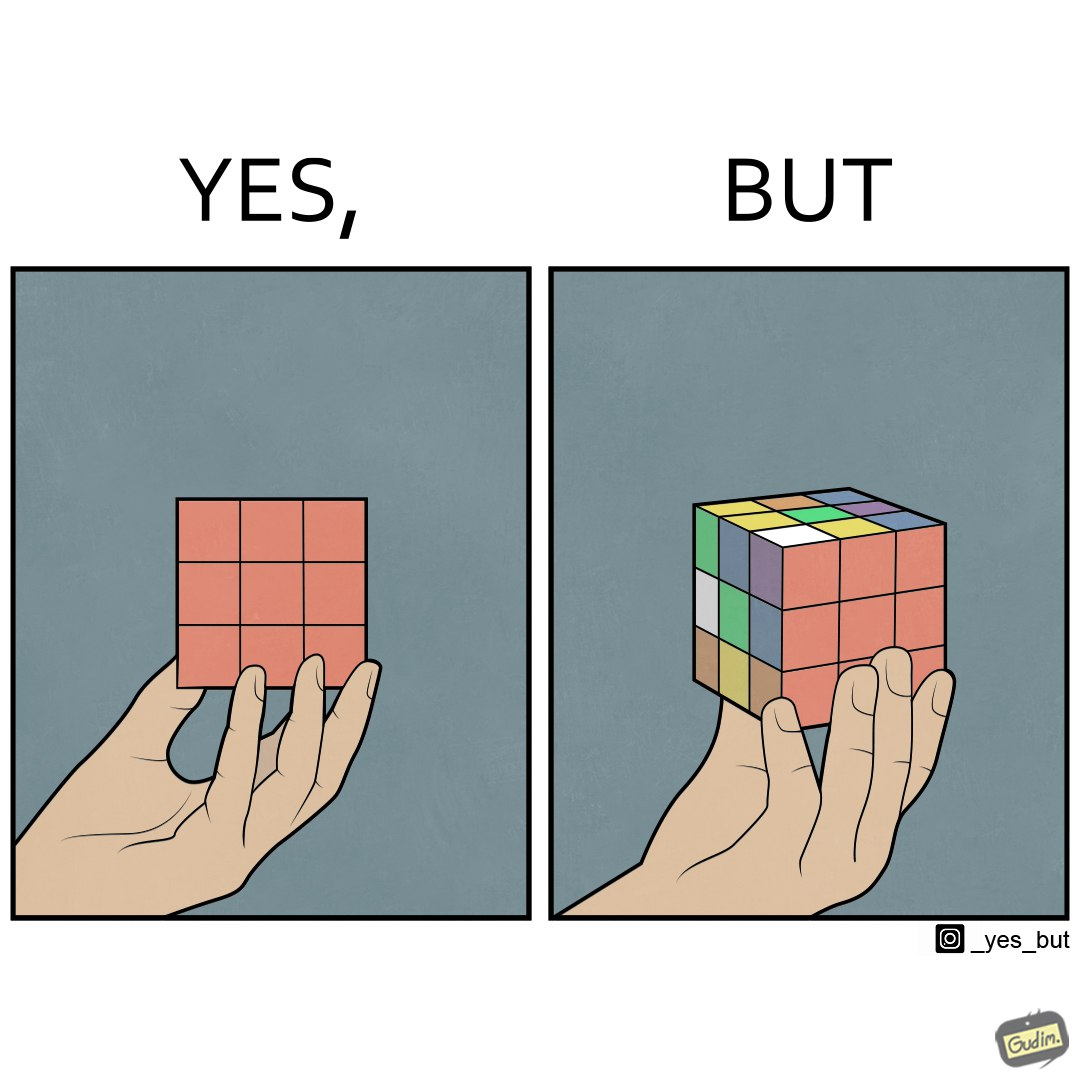What makes this image funny or satirical? The images are funny since they show how a jumbled rubiks cube appears solved simply because of the viewers perspective. 